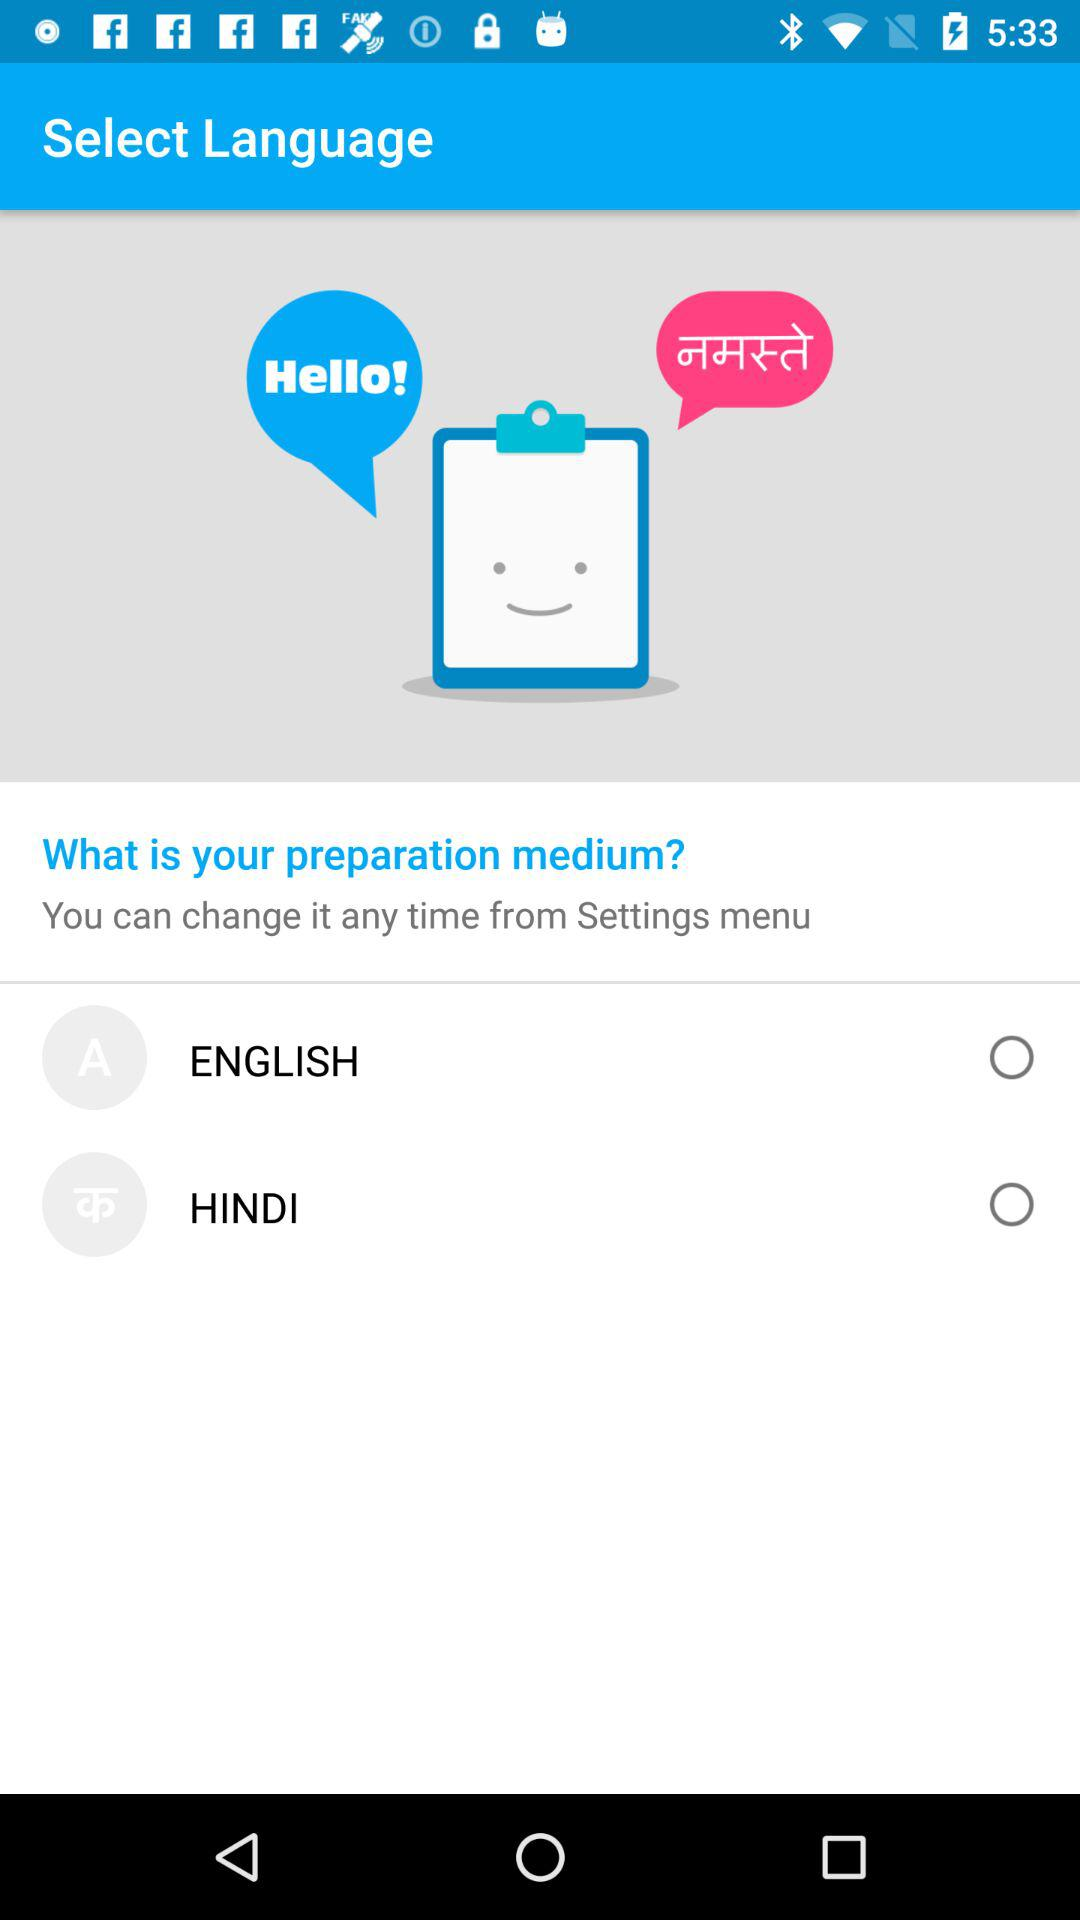How many languages are available for selection?
Answer the question using a single word or phrase. 2 